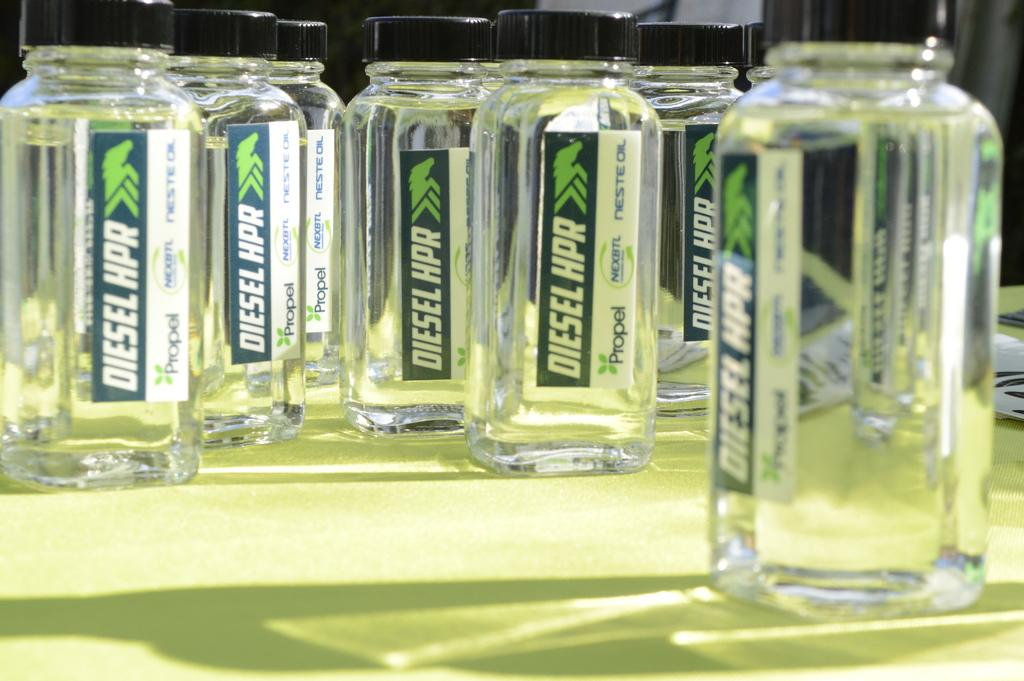<image>
Write a terse but informative summary of the picture. Bottles have the brand name Diesel on them. 